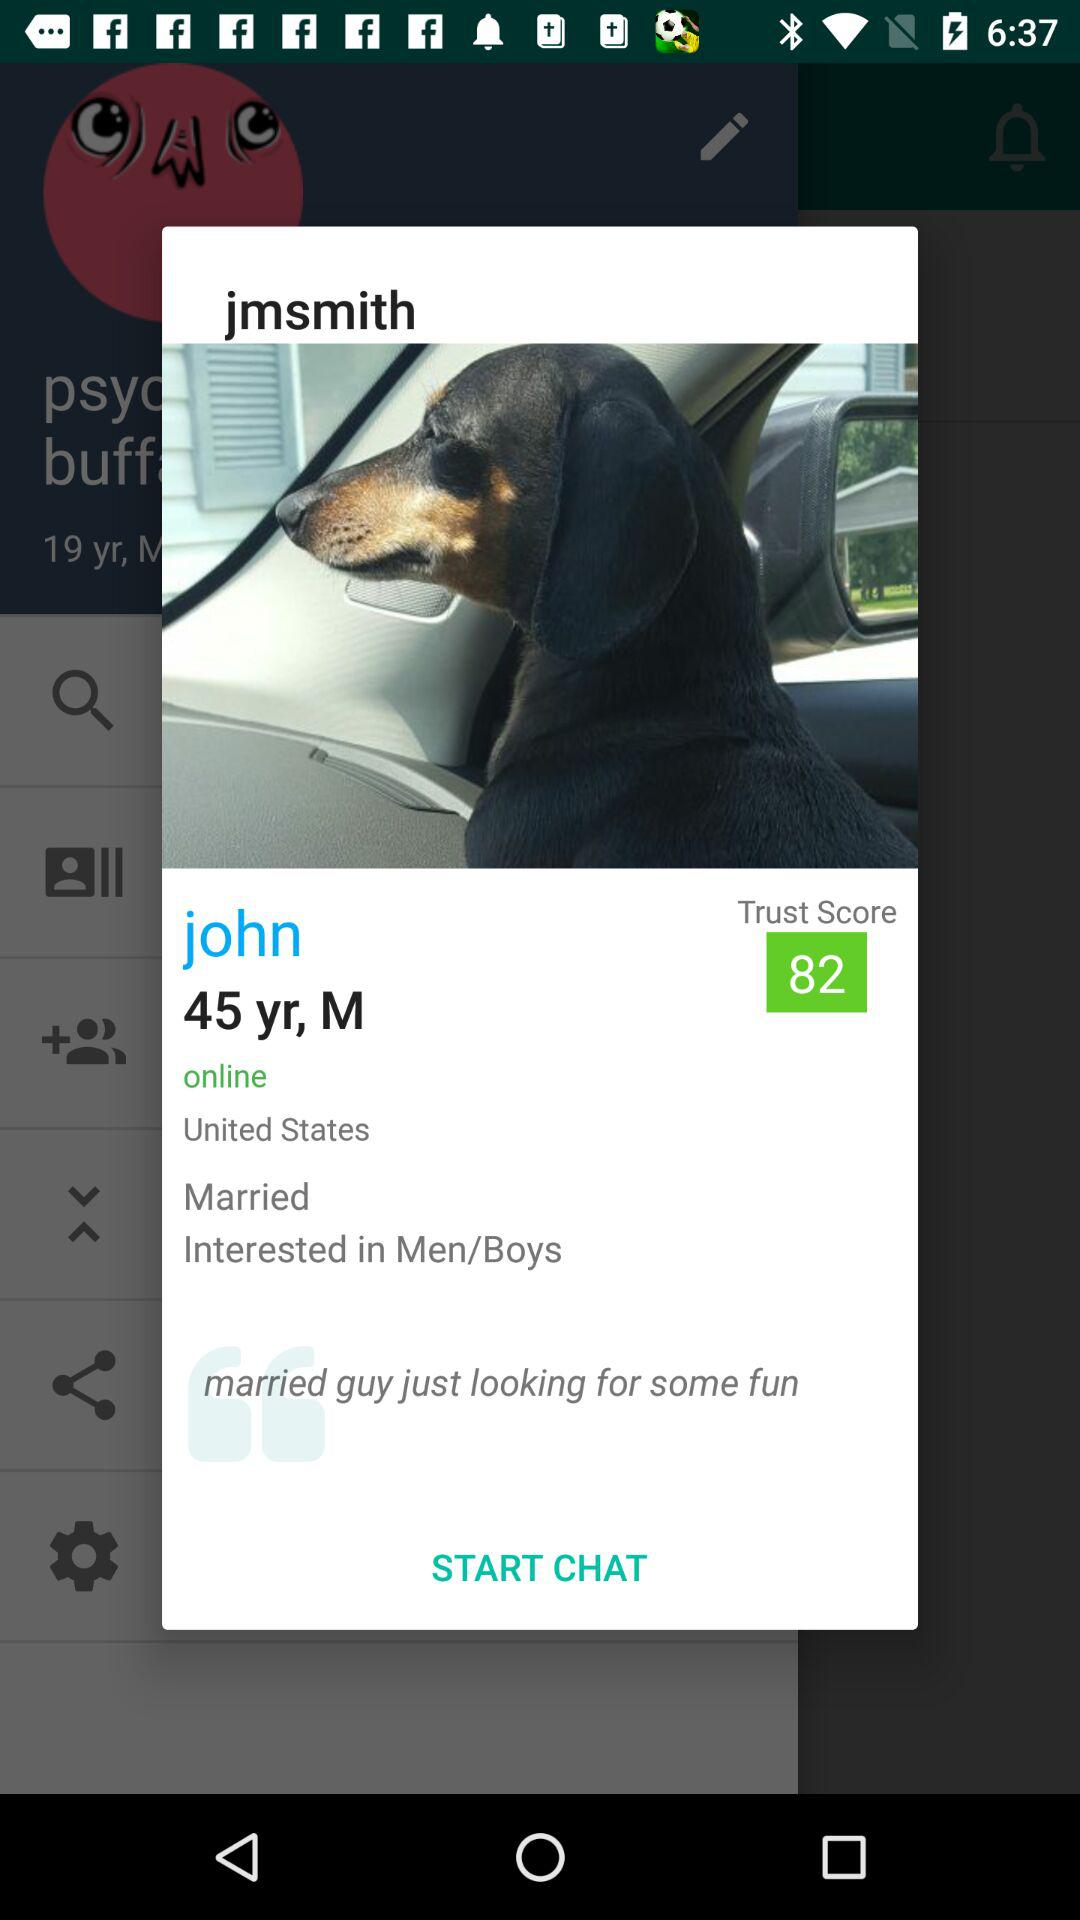What is the user looking for? The user is looking for some fun. 